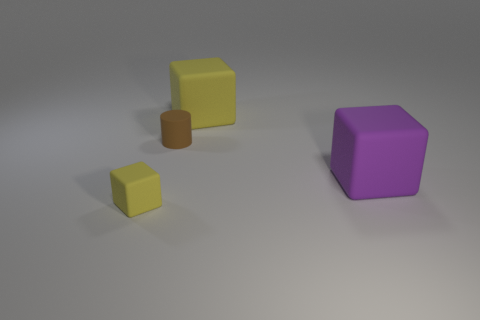Add 2 tiny matte cylinders. How many objects exist? 6 Subtract all cubes. How many objects are left? 1 Add 1 purple rubber things. How many purple rubber things are left? 2 Add 2 brown objects. How many brown objects exist? 3 Subtract 1 purple blocks. How many objects are left? 3 Subtract all gray metallic spheres. Subtract all purple things. How many objects are left? 3 